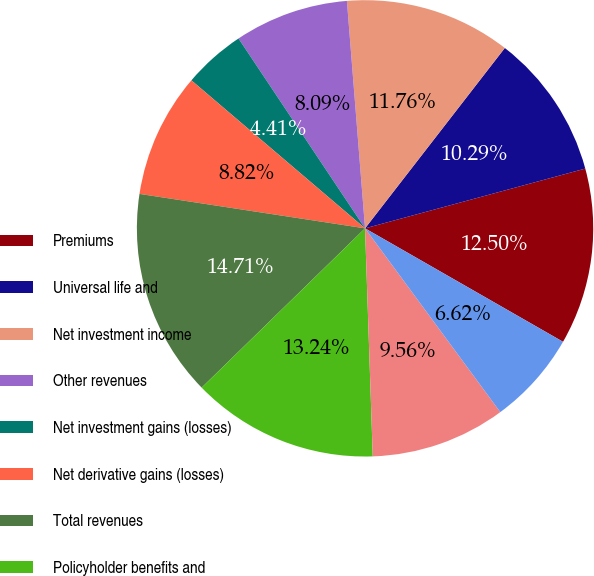<chart> <loc_0><loc_0><loc_500><loc_500><pie_chart><fcel>Premiums<fcel>Universal life and<fcel>Net investment income<fcel>Other revenues<fcel>Net investment gains (losses)<fcel>Net derivative gains (losses)<fcel>Total revenues<fcel>Policyholder benefits and<fcel>Interest credited to<fcel>Policyholder dividends<nl><fcel>12.5%<fcel>10.29%<fcel>11.76%<fcel>8.09%<fcel>4.41%<fcel>8.82%<fcel>14.71%<fcel>13.24%<fcel>9.56%<fcel>6.62%<nl></chart> 